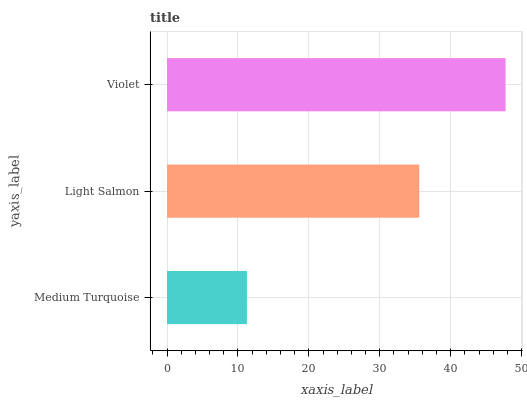Is Medium Turquoise the minimum?
Answer yes or no. Yes. Is Violet the maximum?
Answer yes or no. Yes. Is Light Salmon the minimum?
Answer yes or no. No. Is Light Salmon the maximum?
Answer yes or no. No. Is Light Salmon greater than Medium Turquoise?
Answer yes or no. Yes. Is Medium Turquoise less than Light Salmon?
Answer yes or no. Yes. Is Medium Turquoise greater than Light Salmon?
Answer yes or no. No. Is Light Salmon less than Medium Turquoise?
Answer yes or no. No. Is Light Salmon the high median?
Answer yes or no. Yes. Is Light Salmon the low median?
Answer yes or no. Yes. Is Violet the high median?
Answer yes or no. No. Is Medium Turquoise the low median?
Answer yes or no. No. 